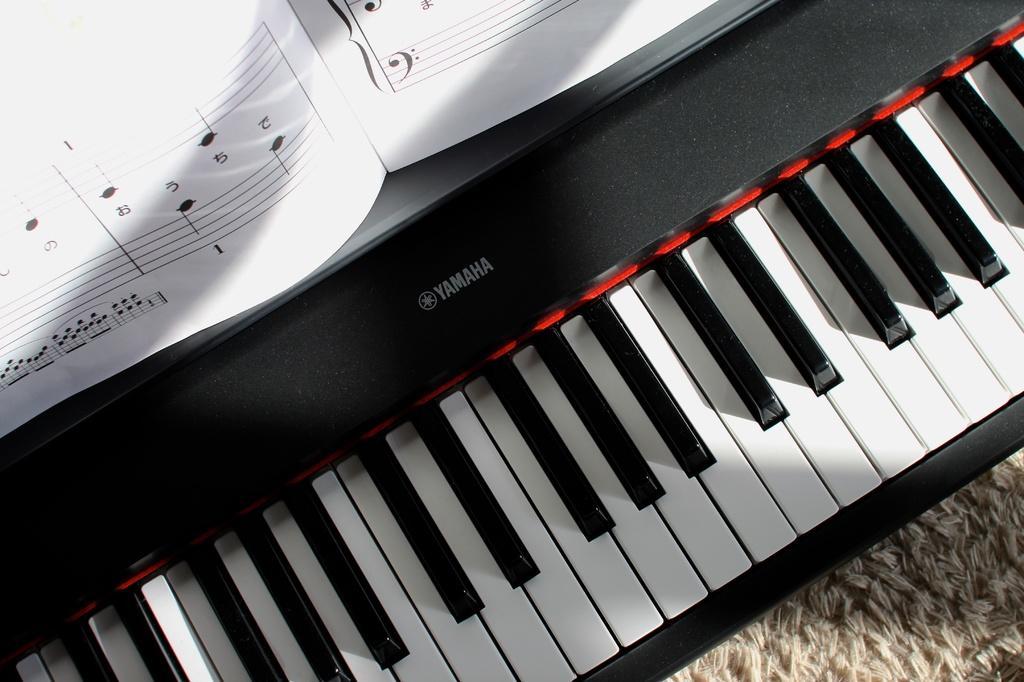How would you summarize this image in a sentence or two? This image consists of a keyboard. It has white keys and black keys and Yamaha is written on it. There is a paper on the keyboard. 